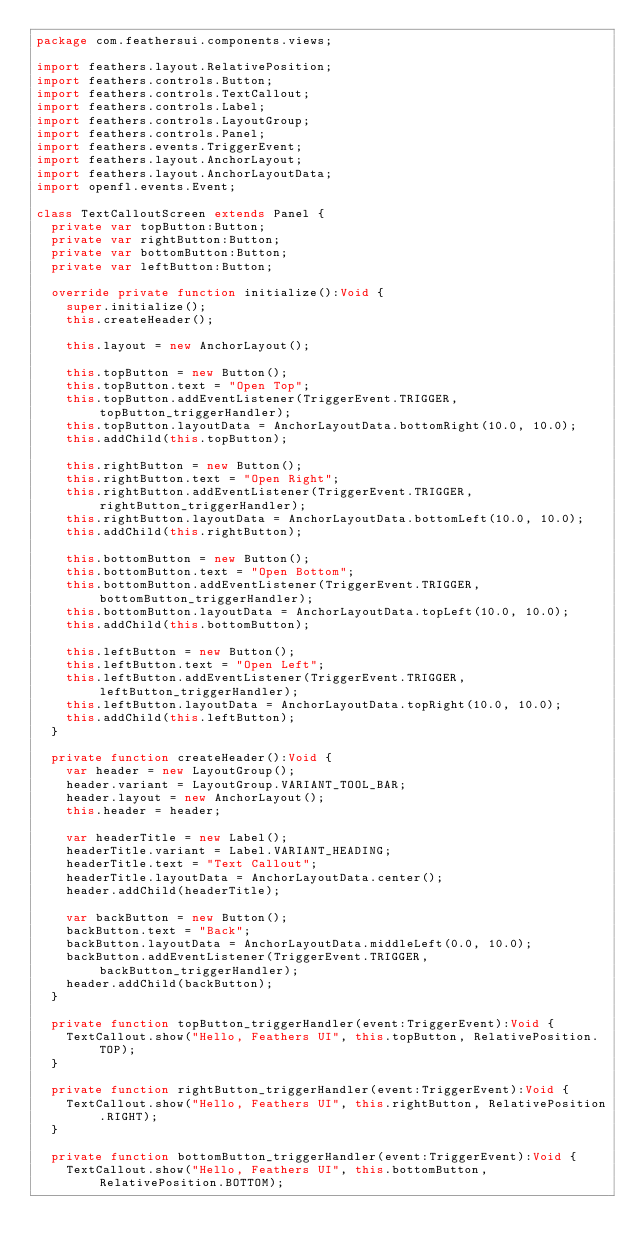<code> <loc_0><loc_0><loc_500><loc_500><_Haxe_>package com.feathersui.components.views;

import feathers.layout.RelativePosition;
import feathers.controls.Button;
import feathers.controls.TextCallout;
import feathers.controls.Label;
import feathers.controls.LayoutGroup;
import feathers.controls.Panel;
import feathers.events.TriggerEvent;
import feathers.layout.AnchorLayout;
import feathers.layout.AnchorLayoutData;
import openfl.events.Event;

class TextCalloutScreen extends Panel {
	private var topButton:Button;
	private var rightButton:Button;
	private var bottomButton:Button;
	private var leftButton:Button;

	override private function initialize():Void {
		super.initialize();
		this.createHeader();

		this.layout = new AnchorLayout();

		this.topButton = new Button();
		this.topButton.text = "Open Top";
		this.topButton.addEventListener(TriggerEvent.TRIGGER, topButton_triggerHandler);
		this.topButton.layoutData = AnchorLayoutData.bottomRight(10.0, 10.0);
		this.addChild(this.topButton);

		this.rightButton = new Button();
		this.rightButton.text = "Open Right";
		this.rightButton.addEventListener(TriggerEvent.TRIGGER, rightButton_triggerHandler);
		this.rightButton.layoutData = AnchorLayoutData.bottomLeft(10.0, 10.0);
		this.addChild(this.rightButton);

		this.bottomButton = new Button();
		this.bottomButton.text = "Open Bottom";
		this.bottomButton.addEventListener(TriggerEvent.TRIGGER, bottomButton_triggerHandler);
		this.bottomButton.layoutData = AnchorLayoutData.topLeft(10.0, 10.0);
		this.addChild(this.bottomButton);

		this.leftButton = new Button();
		this.leftButton.text = "Open Left";
		this.leftButton.addEventListener(TriggerEvent.TRIGGER, leftButton_triggerHandler);
		this.leftButton.layoutData = AnchorLayoutData.topRight(10.0, 10.0);
		this.addChild(this.leftButton);
	}

	private function createHeader():Void {
		var header = new LayoutGroup();
		header.variant = LayoutGroup.VARIANT_TOOL_BAR;
		header.layout = new AnchorLayout();
		this.header = header;

		var headerTitle = new Label();
		headerTitle.variant = Label.VARIANT_HEADING;
		headerTitle.text = "Text Callout";
		headerTitle.layoutData = AnchorLayoutData.center();
		header.addChild(headerTitle);

		var backButton = new Button();
		backButton.text = "Back";
		backButton.layoutData = AnchorLayoutData.middleLeft(0.0, 10.0);
		backButton.addEventListener(TriggerEvent.TRIGGER, backButton_triggerHandler);
		header.addChild(backButton);
	}

	private function topButton_triggerHandler(event:TriggerEvent):Void {
		TextCallout.show("Hello, Feathers UI", this.topButton, RelativePosition.TOP);
	}

	private function rightButton_triggerHandler(event:TriggerEvent):Void {
		TextCallout.show("Hello, Feathers UI", this.rightButton, RelativePosition.RIGHT);
	}

	private function bottomButton_triggerHandler(event:TriggerEvent):Void {
		TextCallout.show("Hello, Feathers UI", this.bottomButton, RelativePosition.BOTTOM);</code> 